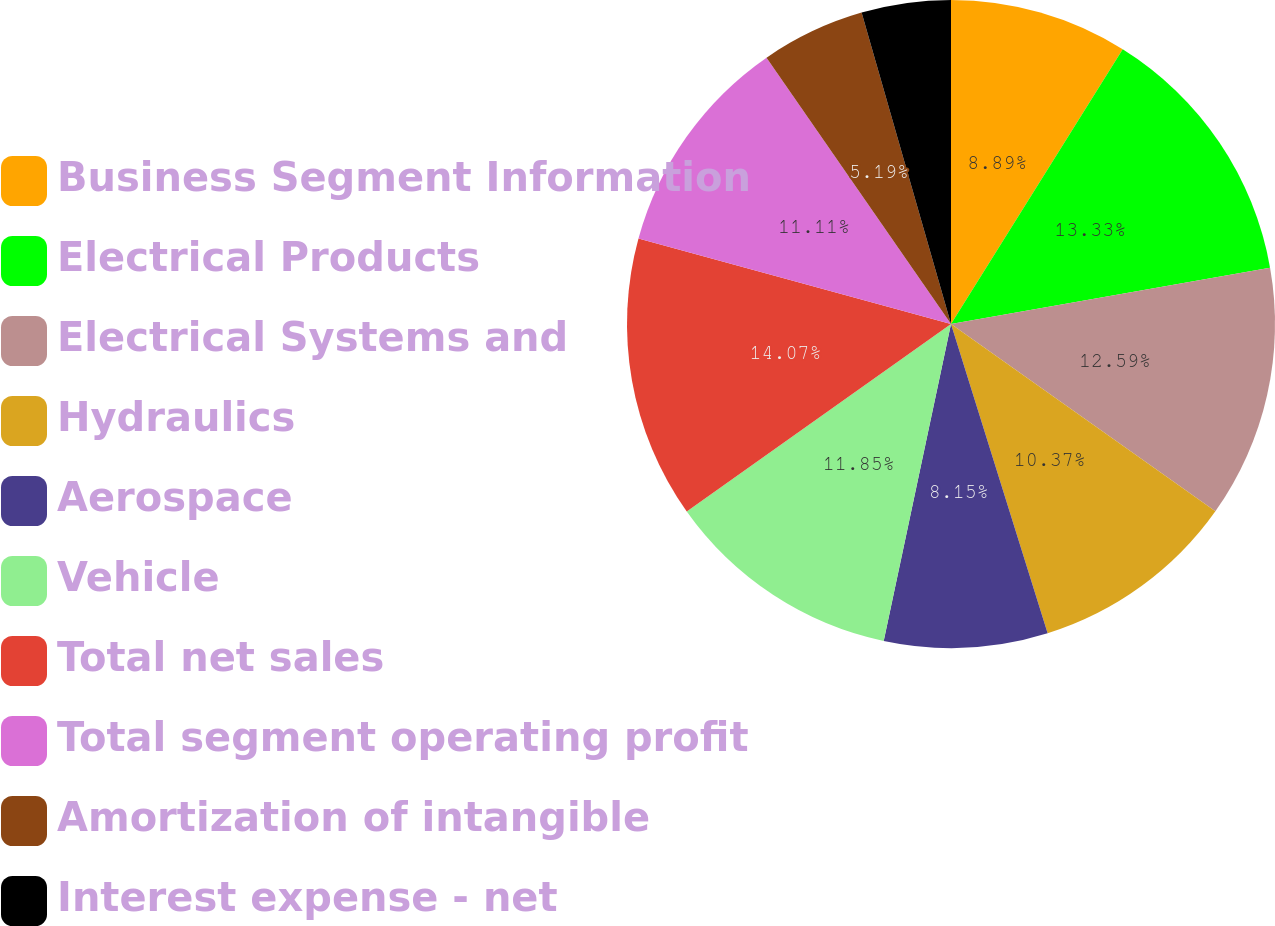Convert chart. <chart><loc_0><loc_0><loc_500><loc_500><pie_chart><fcel>Business Segment Information<fcel>Electrical Products<fcel>Electrical Systems and<fcel>Hydraulics<fcel>Aerospace<fcel>Vehicle<fcel>Total net sales<fcel>Total segment operating profit<fcel>Amortization of intangible<fcel>Interest expense - net<nl><fcel>8.89%<fcel>13.33%<fcel>12.59%<fcel>10.37%<fcel>8.15%<fcel>11.85%<fcel>14.07%<fcel>11.11%<fcel>5.19%<fcel>4.45%<nl></chart> 